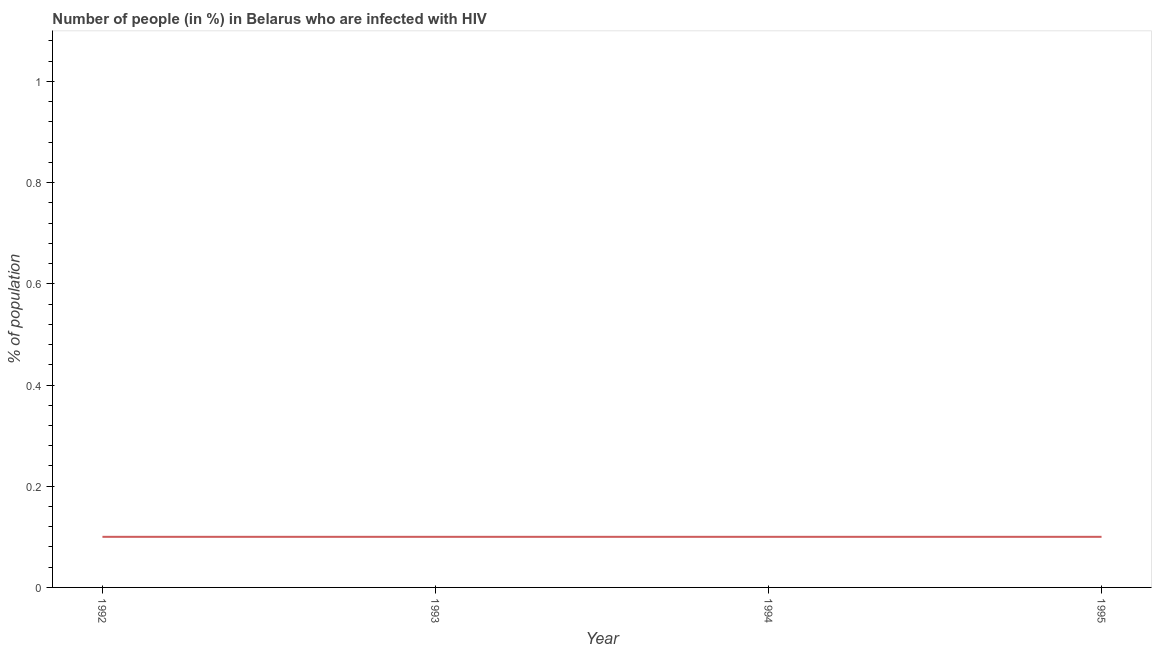What is the number of people infected with hiv in 1995?
Provide a succinct answer. 0.1. In which year was the number of people infected with hiv minimum?
Give a very brief answer. 1992. What is the sum of the number of people infected with hiv?
Provide a succinct answer. 0.4. What is the ratio of the number of people infected with hiv in 1994 to that in 1995?
Your response must be concise. 1. What is the difference between the highest and the lowest number of people infected with hiv?
Your response must be concise. 0. In how many years, is the number of people infected with hiv greater than the average number of people infected with hiv taken over all years?
Your answer should be very brief. 0. Does the number of people infected with hiv monotonically increase over the years?
Your answer should be compact. No. How many lines are there?
Your response must be concise. 1. How many years are there in the graph?
Your response must be concise. 4. Does the graph contain any zero values?
Your answer should be very brief. No. What is the title of the graph?
Your answer should be very brief. Number of people (in %) in Belarus who are infected with HIV. What is the label or title of the Y-axis?
Your answer should be very brief. % of population. What is the % of population of 1992?
Offer a terse response. 0.1. What is the % of population in 1995?
Offer a terse response. 0.1. What is the difference between the % of population in 1993 and 1994?
Provide a short and direct response. 0. What is the difference between the % of population in 1994 and 1995?
Make the answer very short. 0. What is the ratio of the % of population in 1992 to that in 1994?
Ensure brevity in your answer.  1. 